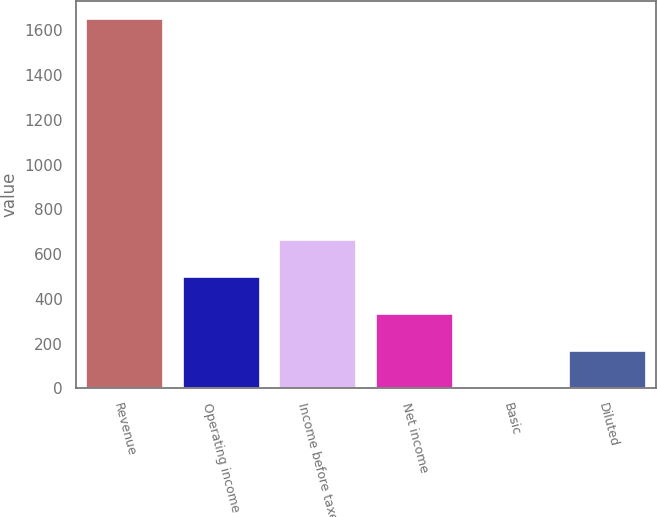Convert chart to OTSL. <chart><loc_0><loc_0><loc_500><loc_500><bar_chart><fcel>Revenue<fcel>Operating income<fcel>Income before taxes<fcel>Net income<fcel>Basic<fcel>Diluted<nl><fcel>1650.8<fcel>496.26<fcel>661.2<fcel>331.32<fcel>1.44<fcel>166.38<nl></chart> 